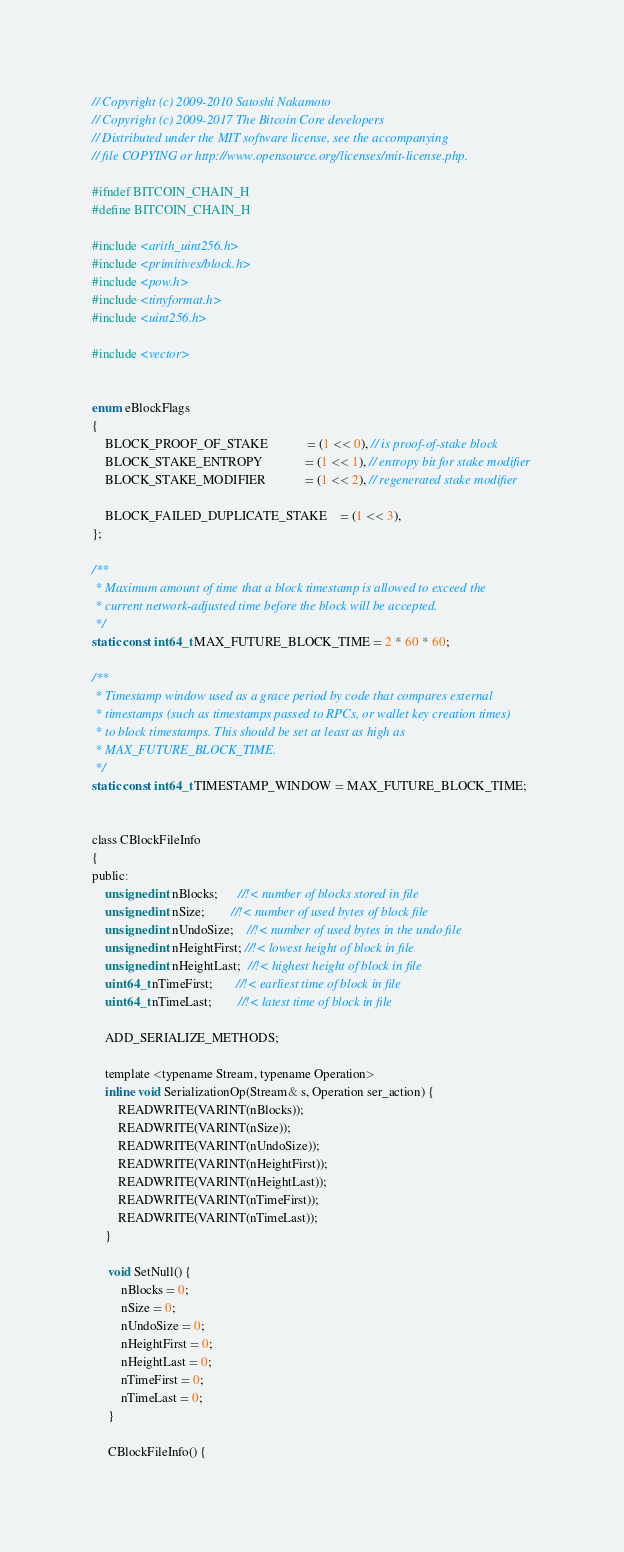Convert code to text. <code><loc_0><loc_0><loc_500><loc_500><_C_>// Copyright (c) 2009-2010 Satoshi Nakamoto
// Copyright (c) 2009-2017 The Bitcoin Core developers
// Distributed under the MIT software license, see the accompanying
// file COPYING or http://www.opensource.org/licenses/mit-license.php.

#ifndef BITCOIN_CHAIN_H
#define BITCOIN_CHAIN_H

#include <arith_uint256.h>
#include <primitives/block.h>
#include <pow.h>
#include <tinyformat.h>
#include <uint256.h>

#include <vector>


enum eBlockFlags
{
    BLOCK_PROOF_OF_STAKE            = (1 << 0), // is proof-of-stake block
    BLOCK_STAKE_ENTROPY             = (1 << 1), // entropy bit for stake modifier
    BLOCK_STAKE_MODIFIER            = (1 << 2), // regenerated stake modifier

    BLOCK_FAILED_DUPLICATE_STAKE    = (1 << 3),
};

/**
 * Maximum amount of time that a block timestamp is allowed to exceed the
 * current network-adjusted time before the block will be accepted.
 */
static const int64_t MAX_FUTURE_BLOCK_TIME = 2 * 60 * 60;

/**
 * Timestamp window used as a grace period by code that compares external
 * timestamps (such as timestamps passed to RPCs, or wallet key creation times)
 * to block timestamps. This should be set at least as high as
 * MAX_FUTURE_BLOCK_TIME.
 */
static const int64_t TIMESTAMP_WINDOW = MAX_FUTURE_BLOCK_TIME;


class CBlockFileInfo
{
public:
    unsigned int nBlocks;      //!< number of blocks stored in file
    unsigned int nSize;        //!< number of used bytes of block file
    unsigned int nUndoSize;    //!< number of used bytes in the undo file
    unsigned int nHeightFirst; //!< lowest height of block in file
    unsigned int nHeightLast;  //!< highest height of block in file
    uint64_t nTimeFirst;       //!< earliest time of block in file
    uint64_t nTimeLast;        //!< latest time of block in file

    ADD_SERIALIZE_METHODS;

    template <typename Stream, typename Operation>
    inline void SerializationOp(Stream& s, Operation ser_action) {
        READWRITE(VARINT(nBlocks));
        READWRITE(VARINT(nSize));
        READWRITE(VARINT(nUndoSize));
        READWRITE(VARINT(nHeightFirst));
        READWRITE(VARINT(nHeightLast));
        READWRITE(VARINT(nTimeFirst));
        READWRITE(VARINT(nTimeLast));
    }

     void SetNull() {
         nBlocks = 0;
         nSize = 0;
         nUndoSize = 0;
         nHeightFirst = 0;
         nHeightLast = 0;
         nTimeFirst = 0;
         nTimeLast = 0;
     }

     CBlockFileInfo() {</code> 